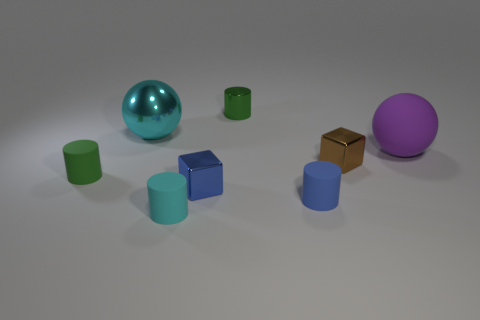Subtract all tiny blue cylinders. How many cylinders are left? 3 Subtract all cyan cylinders. How many cylinders are left? 3 Subtract all blue spheres. How many green cylinders are left? 2 Subtract 1 blocks. How many blocks are left? 1 Add 1 tiny metal cylinders. How many objects exist? 9 Subtract all spheres. How many objects are left? 6 Subtract all brown cylinders. Subtract all purple blocks. How many cylinders are left? 4 Add 5 tiny blue objects. How many tiny blue objects exist? 7 Subtract 0 red cubes. How many objects are left? 8 Subtract all balls. Subtract all rubber objects. How many objects are left? 2 